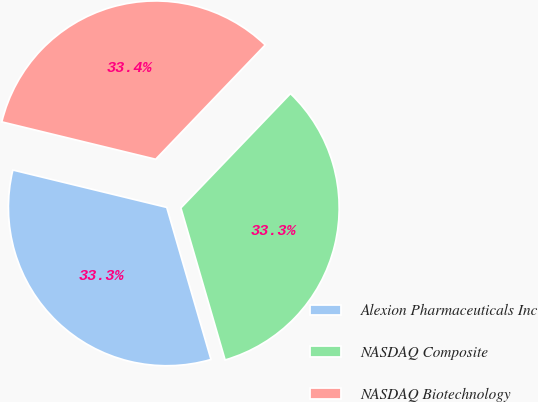<chart> <loc_0><loc_0><loc_500><loc_500><pie_chart><fcel>Alexion Pharmaceuticals Inc<fcel>NASDAQ Composite<fcel>NASDAQ Biotechnology<nl><fcel>33.3%<fcel>33.33%<fcel>33.37%<nl></chart> 